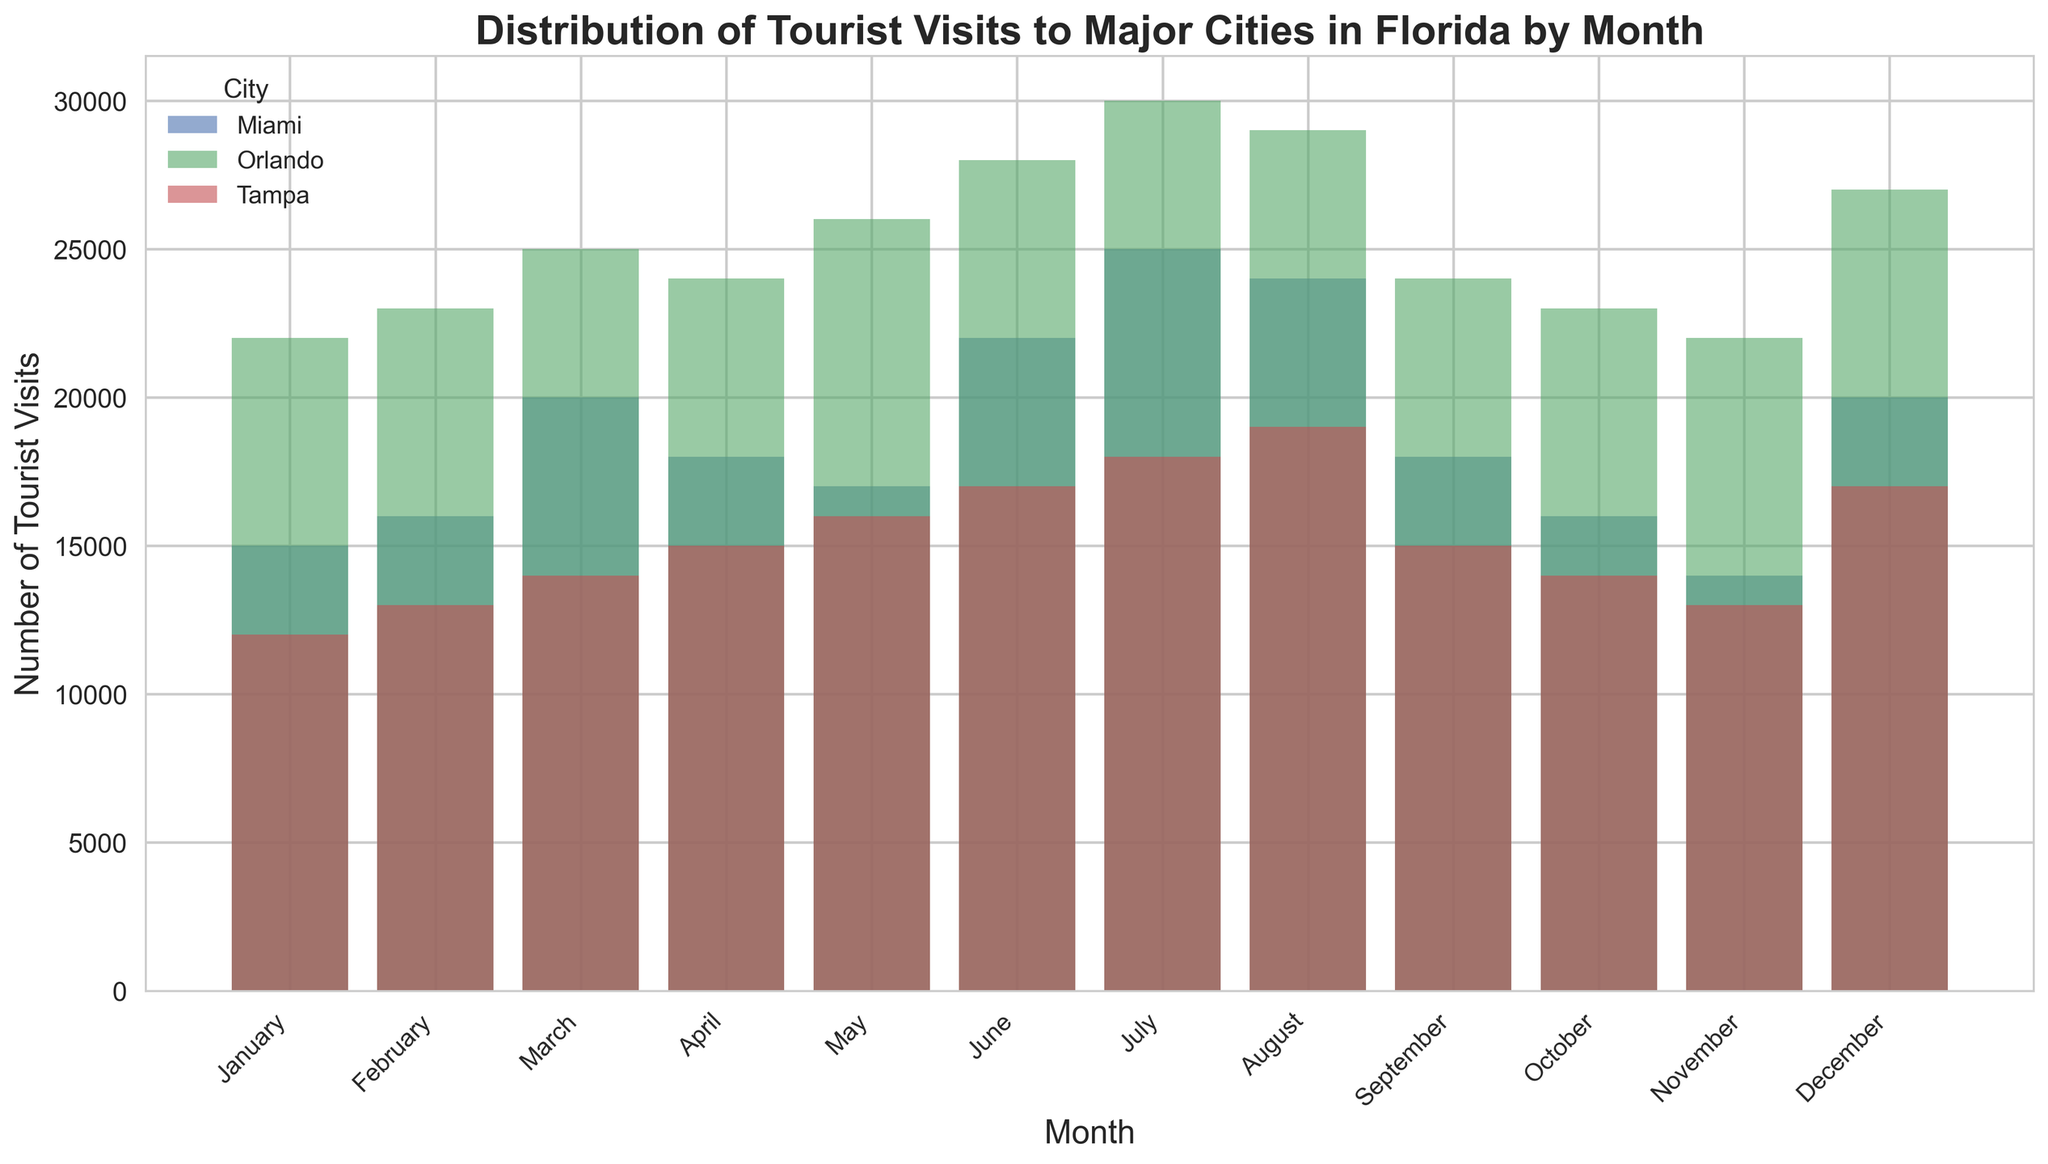What's the busiest month for tourist visits in Miami? Look at the height of the bars for Miami in each month, and identify the tallest one. In this case, the bar in July is the tallest with 25,000 visits.
Answer: July Which city had the highest number of tourist visits in December? Compare the height of the bars for each city in December. Orlando has the highest with 27,000 visits.
Answer: Orlando What's the difference in tourist visits between Orlando and Tampa in June? Subtract Tampa's tourist visits in June (17,000) from Orlando's (28,000). The difference is 28,000 - 17,000 = 11,000.
Answer: 11,000 What is the total number of tourist visits to Miami across all months? Sum the tourist visits for Miami for each month: 15,000 + 16,000 + 20,000 + 18,000 + 17,000 + 22,000 + 25,000 + 24,000 + 18,000 + 16,000 + 14,000 + 20,000 = 225,000.
Answer: 225,000 Which two months have the least difference in tourist visits between Miami and Orlando? Calculate the difference in tourist visits between Miami and Orlando for each month and identify the smallest differences. The smallest differences are 2,000 for both May (26,000 - 17,000) and January (22,000 - 15,000).
Answer: May and January How does the number of tourist visits to Tampa in July compare to the number of visits to Miami in the same month? Compare the height of the July bars for both cities. Tampa has 18,000 visits, and Miami has 25,000 visits. Therefore, Miami has more visits in July.
Answer: Miami has more visits During which month was the difference between tourist visits in Miami and Tampa the largest? Look for the month where the gap between the bars for Miami and Tampa is biggest. In July, Miami has 25,000 visits, and Tampa has 18,000 visits, hence the difference is 7,000.
Answer: July What is the average number of tourist visits to Orlando per month? Sum tourist visits to Orlando for each month and divide by 12: (22,000 + 23,000 + 25,000 + 24,000 + 26,000 + 28,000 + 30,000 + 29,000 + 24,000 + 23,000 + 22,000 + 27,000) / 12 = 25,000.
Answer: 25,000 